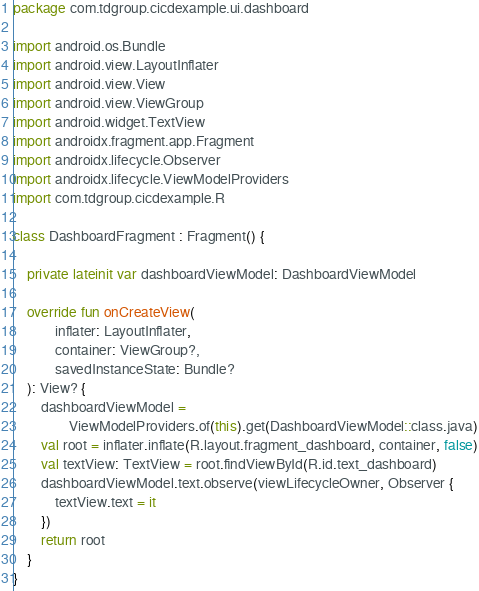Convert code to text. <code><loc_0><loc_0><loc_500><loc_500><_Kotlin_>package com.tdgroup.cicdexample.ui.dashboard

import android.os.Bundle
import android.view.LayoutInflater
import android.view.View
import android.view.ViewGroup
import android.widget.TextView
import androidx.fragment.app.Fragment
import androidx.lifecycle.Observer
import androidx.lifecycle.ViewModelProviders
import com.tdgroup.cicdexample.R

class DashboardFragment : Fragment() {

    private lateinit var dashboardViewModel: DashboardViewModel

    override fun onCreateView(
            inflater: LayoutInflater,
            container: ViewGroup?,
            savedInstanceState: Bundle?
    ): View? {
        dashboardViewModel =
                ViewModelProviders.of(this).get(DashboardViewModel::class.java)
        val root = inflater.inflate(R.layout.fragment_dashboard, container, false)
        val textView: TextView = root.findViewById(R.id.text_dashboard)
        dashboardViewModel.text.observe(viewLifecycleOwner, Observer {
            textView.text = it
        })
        return root
    }
}</code> 